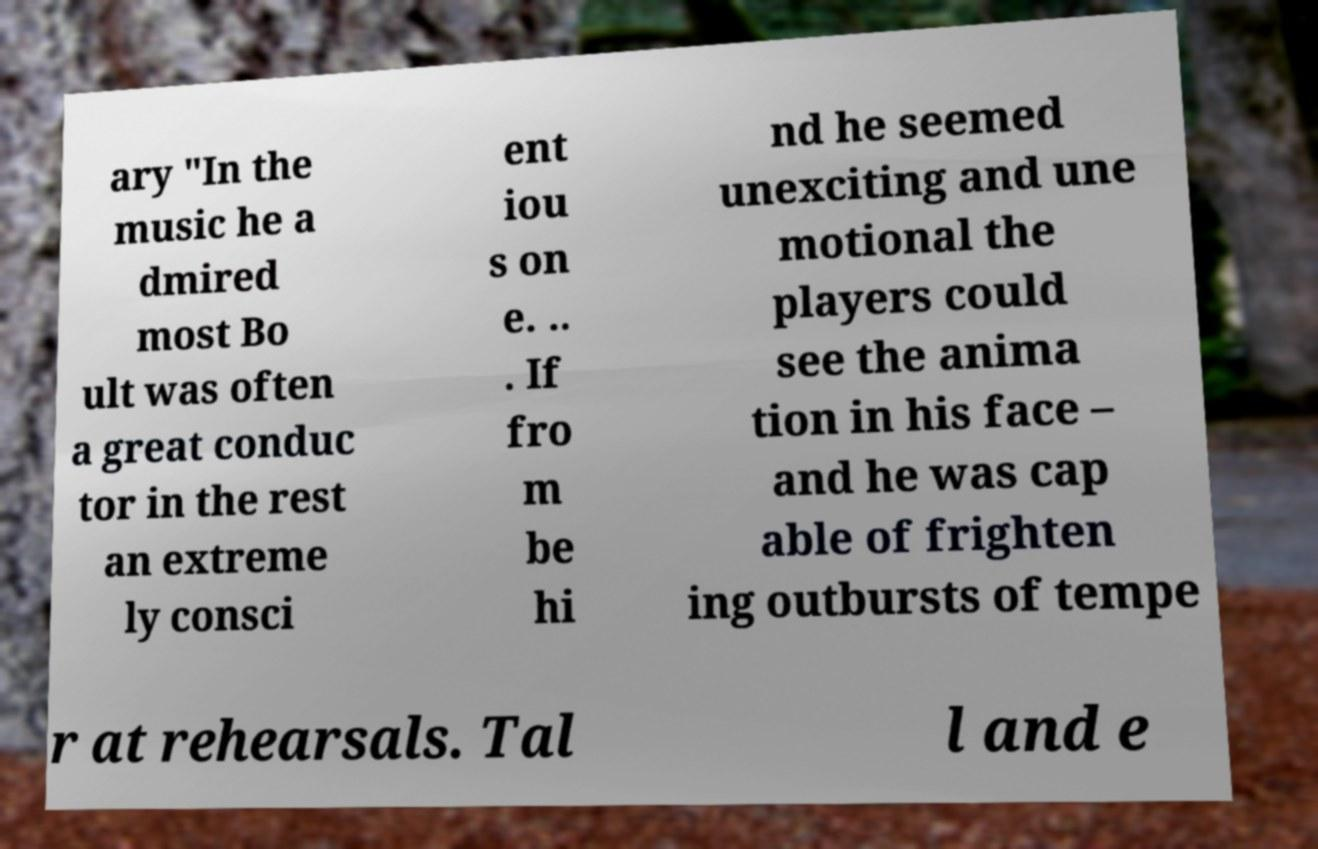Please identify and transcribe the text found in this image. ary "In the music he a dmired most Bo ult was often a great conduc tor in the rest an extreme ly consci ent iou s on e. .. . If fro m be hi nd he seemed unexciting and une motional the players could see the anima tion in his face – and he was cap able of frighten ing outbursts of tempe r at rehearsals. Tal l and e 